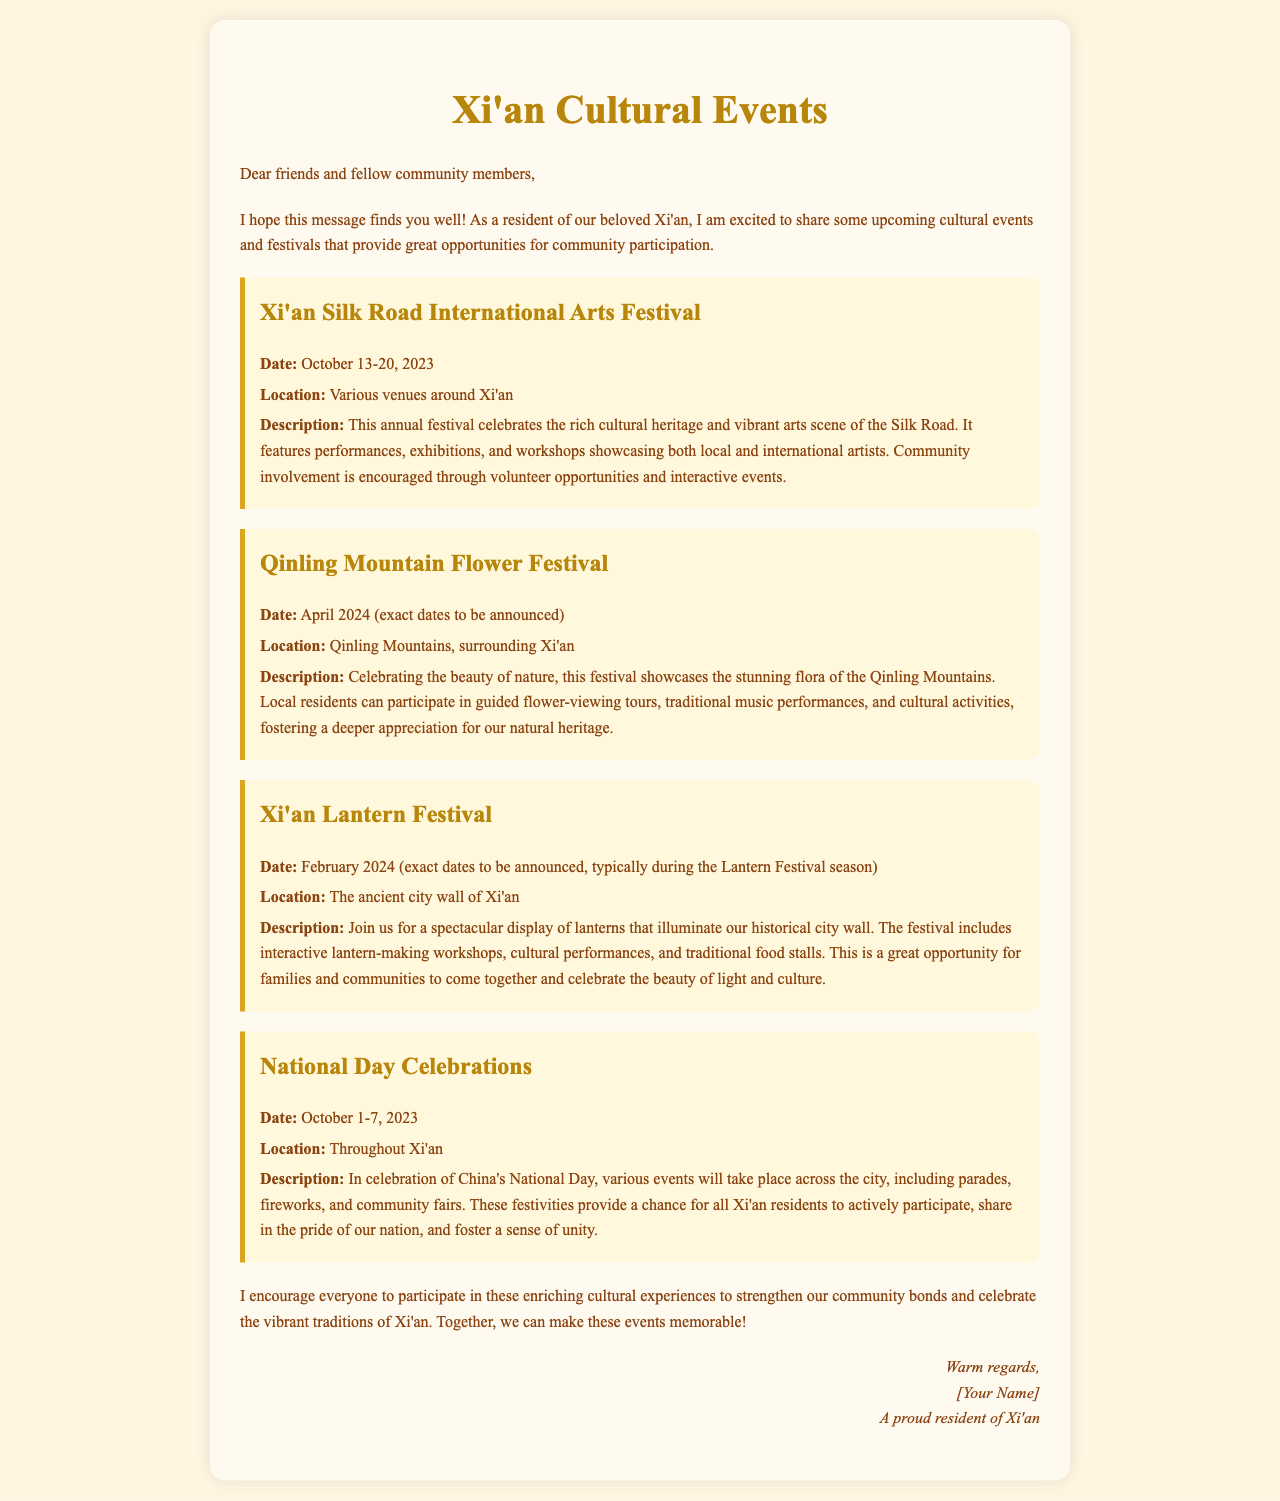what is the date of the Xi'an Silk Road International Arts Festival? The festival is scheduled to take place from October 13-20, 2023.
Answer: October 13-20, 2023 where is the Qinling Mountain Flower Festival held? The festival takes place in the Qinling Mountains, surrounding Xi'an.
Answer: Qinling Mountains what type of activities are included in the Xi'an Lantern Festival? It includes lantern-making workshops, cultural performances, and traditional food stalls.
Answer: lantern-making workshops, cultural performances, and traditional food stalls when do the National Day Celebrations occur? The celebrations are from October 1-7, 2023.
Answer: October 1-7, 2023 which event promotes community involvement through volunteer opportunities? The Xi'an Silk Road International Arts Festival encourages community involvement through volunteer opportunities.
Answer: Xi'an Silk Road International Arts Festival how does the Qinling Mountain Flower Festival help local residents? It fosters a deeper appreciation for our natural heritage through guided tours and activities.
Answer: deeper appreciation for our natural heritage what is the main theme of the letter? The main theme is an overview of upcoming cultural events and festivals in Xi'an for community participation.
Answer: upcoming cultural events and festivals in Xi'an who is the author of the letter? The author signs as a proud resident of Xi'an, but their specific name is not provided.
Answer: [Your Name] which event is typically celebrated during the Lantern Festival season? The Xi'an Lantern Festival is celebrated typically during this season.
Answer: Xi'an Lantern Festival 